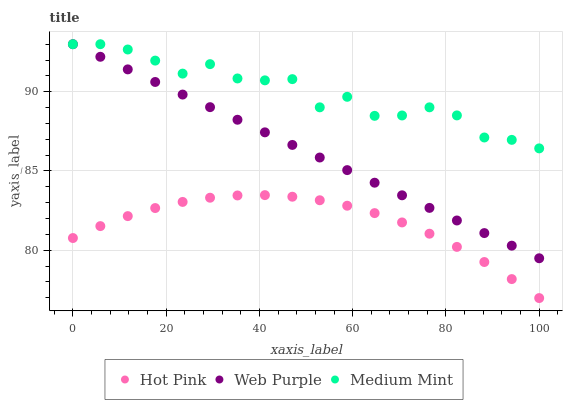Does Hot Pink have the minimum area under the curve?
Answer yes or no. Yes. Does Medium Mint have the maximum area under the curve?
Answer yes or no. Yes. Does Web Purple have the minimum area under the curve?
Answer yes or no. No. Does Web Purple have the maximum area under the curve?
Answer yes or no. No. Is Web Purple the smoothest?
Answer yes or no. Yes. Is Medium Mint the roughest?
Answer yes or no. Yes. Is Hot Pink the smoothest?
Answer yes or no. No. Is Hot Pink the roughest?
Answer yes or no. No. Does Hot Pink have the lowest value?
Answer yes or no. Yes. Does Web Purple have the lowest value?
Answer yes or no. No. Does Web Purple have the highest value?
Answer yes or no. Yes. Does Hot Pink have the highest value?
Answer yes or no. No. Is Hot Pink less than Web Purple?
Answer yes or no. Yes. Is Web Purple greater than Hot Pink?
Answer yes or no. Yes. Does Medium Mint intersect Web Purple?
Answer yes or no. Yes. Is Medium Mint less than Web Purple?
Answer yes or no. No. Is Medium Mint greater than Web Purple?
Answer yes or no. No. Does Hot Pink intersect Web Purple?
Answer yes or no. No. 